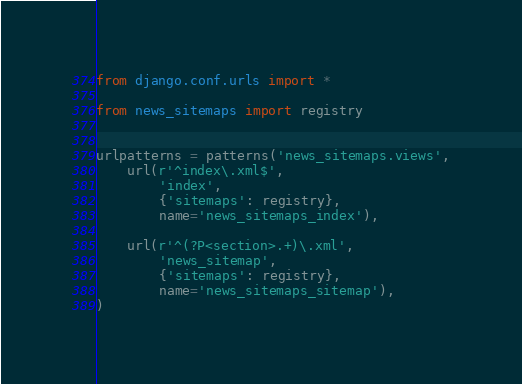Convert code to text. <code><loc_0><loc_0><loc_500><loc_500><_Python_>from django.conf.urls import *

from news_sitemaps import registry


urlpatterns = patterns('news_sitemaps.views',
    url(r'^index\.xml$',
        'index',
        {'sitemaps': registry},
        name='news_sitemaps_index'),

    url(r'^(?P<section>.+)\.xml',
        'news_sitemap',
        {'sitemaps': registry},
        name='news_sitemaps_sitemap'),
)
</code> 